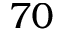Convert formula to latex. <formula><loc_0><loc_0><loc_500><loc_500>7 0</formula> 